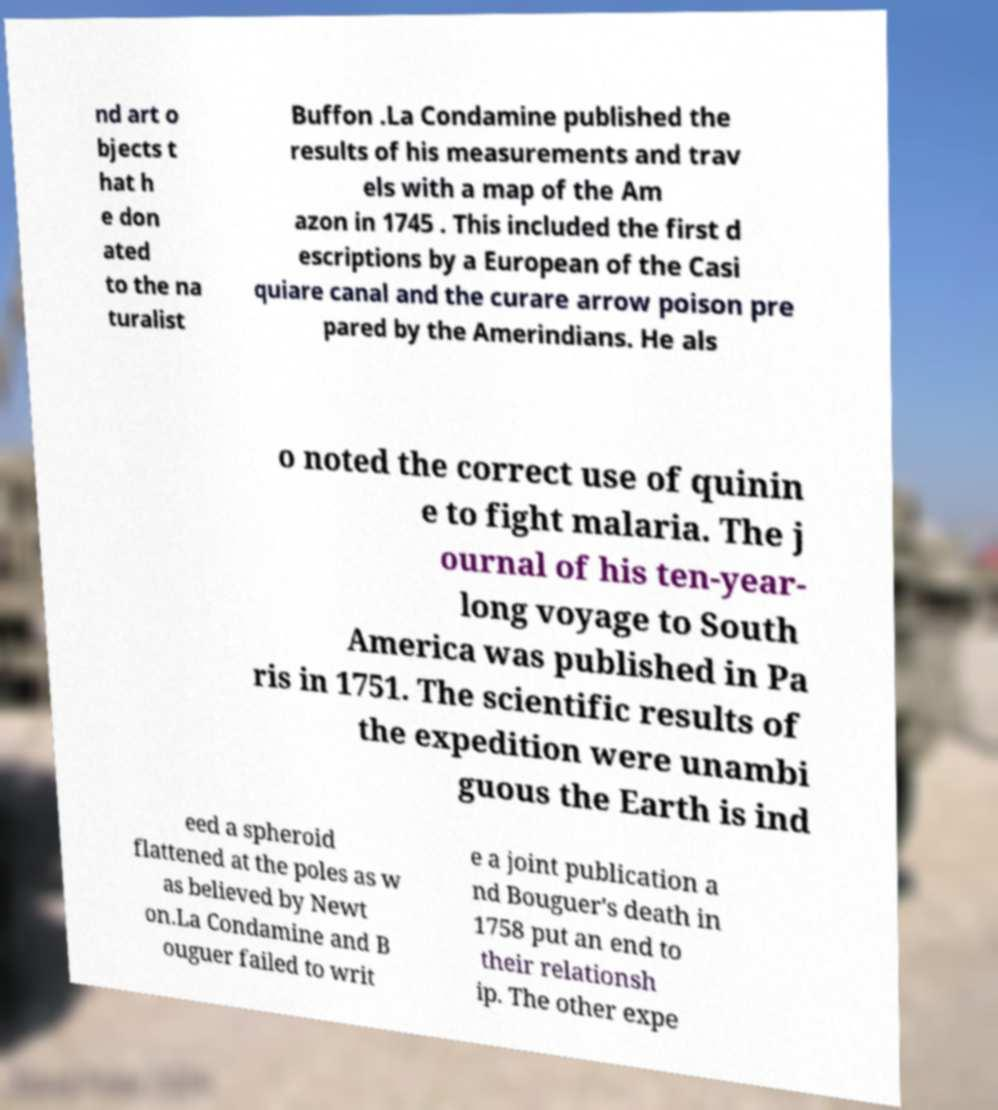For documentation purposes, I need the text within this image transcribed. Could you provide that? nd art o bjects t hat h e don ated to the na turalist Buffon .La Condamine published the results of his measurements and trav els with a map of the Am azon in 1745 . This included the first d escriptions by a European of the Casi quiare canal and the curare arrow poison pre pared by the Amerindians. He als o noted the correct use of quinin e to fight malaria. The j ournal of his ten-year- long voyage to South America was published in Pa ris in 1751. The scientific results of the expedition were unambi guous the Earth is ind eed a spheroid flattened at the poles as w as believed by Newt on.La Condamine and B ouguer failed to writ e a joint publication a nd Bouguer's death in 1758 put an end to their relationsh ip. The other expe 